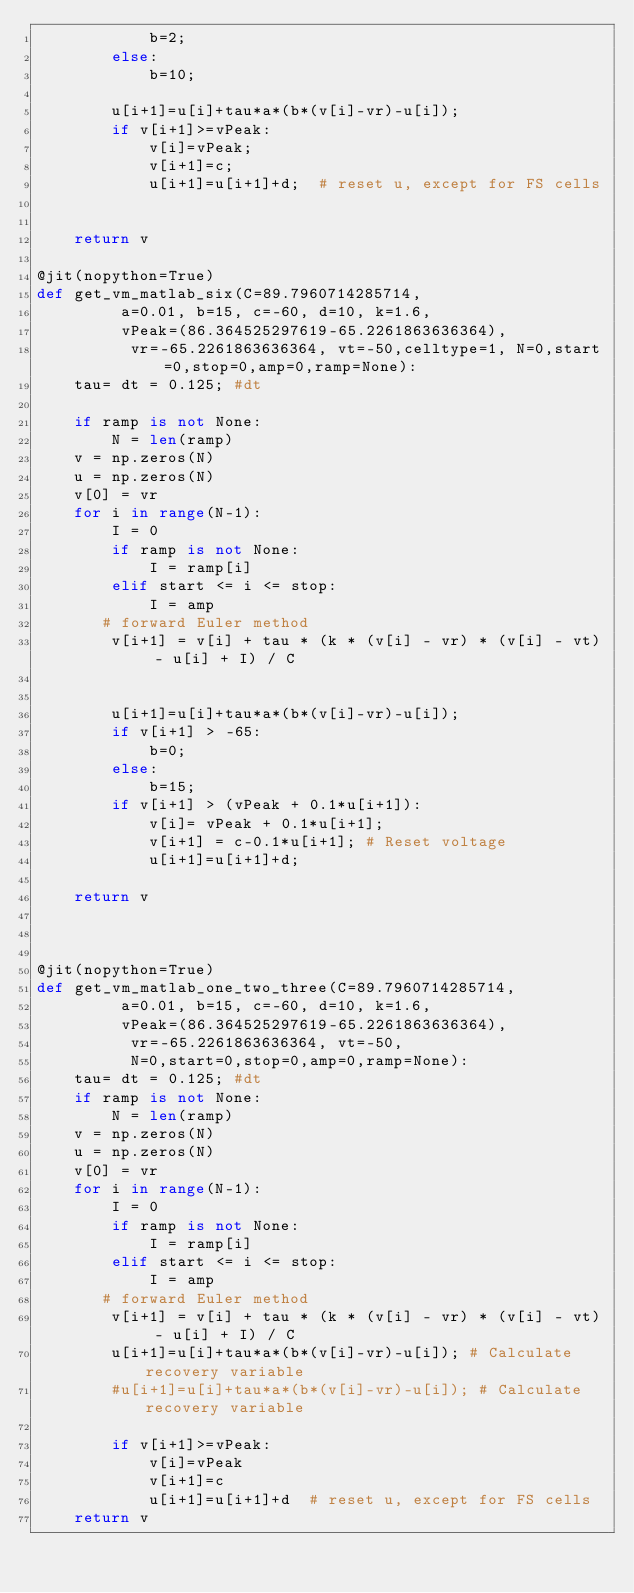<code> <loc_0><loc_0><loc_500><loc_500><_Python_>            b=2;
        else:
            b=10;

        u[i+1]=u[i]+tau*a*(b*(v[i]-vr)-u[i]);
        if v[i+1]>=vPeak:
            v[i]=vPeak;
            v[i+1]=c;
            u[i+1]=u[i+1]+d;  # reset u, except for FS cells


    return v

@jit(nopython=True)
def get_vm_matlab_six(C=89.7960714285714,
         a=0.01, b=15, c=-60, d=10, k=1.6,
         vPeak=(86.364525297619-65.2261863636364),
          vr=-65.2261863636364, vt=-50,celltype=1, N=0,start=0,stop=0,amp=0,ramp=None):
    tau= dt = 0.125; #dt

    if ramp is not None:
        N = len(ramp)
    v = np.zeros(N)
    u = np.zeros(N)
    v[0] = vr
    for i in range(N-1):
        I = 0	
        if ramp is not None:
            I = ramp[i]
        elif start <= i <= stop:
            I = amp
       # forward Euler method
        v[i+1] = v[i] + tau * (k * (v[i] - vr) * (v[i] - vt) - u[i] + I) / C


        u[i+1]=u[i]+tau*a*(b*(v[i]-vr)-u[i]);
        if v[i+1] > -65:
            b=0;
        else:
            b=15;
        if v[i+1] > (vPeak + 0.1*u[i+1]):
            v[i]= vPeak + 0.1*u[i+1];
            v[i+1] = c-0.1*u[i+1]; # Reset voltage
            u[i+1]=u[i+1]+d;

    return v



@jit(nopython=True)
def get_vm_matlab_one_two_three(C=89.7960714285714,
         a=0.01, b=15, c=-60, d=10, k=1.6,
         vPeak=(86.364525297619-65.2261863636364),
          vr=-65.2261863636364, vt=-50,
          N=0,start=0,stop=0,amp=0,ramp=None):
    tau= dt = 0.125; #dt
    if ramp is not None:
        N = len(ramp)
    v = np.zeros(N)
    u = np.zeros(N)
    v[0] = vr
    for i in range(N-1):
        I = 0	
        if ramp is not None:
            I = ramp[i]
        elif start <= i <= stop:
            I = amp
       # forward Euler method
        v[i+1] = v[i] + tau * (k * (v[i] - vr) * (v[i] - vt) - u[i] + I) / C
        u[i+1]=u[i]+tau*a*(b*(v[i]-vr)-u[i]); # Calculate recovery variable
        #u[i+1]=u[i]+tau*a*(b*(v[i]-vr)-u[i]); # Calculate recovery variable

        if v[i+1]>=vPeak:
            v[i]=vPeak
            v[i+1]=c
            u[i+1]=u[i+1]+d  # reset u, except for FS cells
    return v</code> 